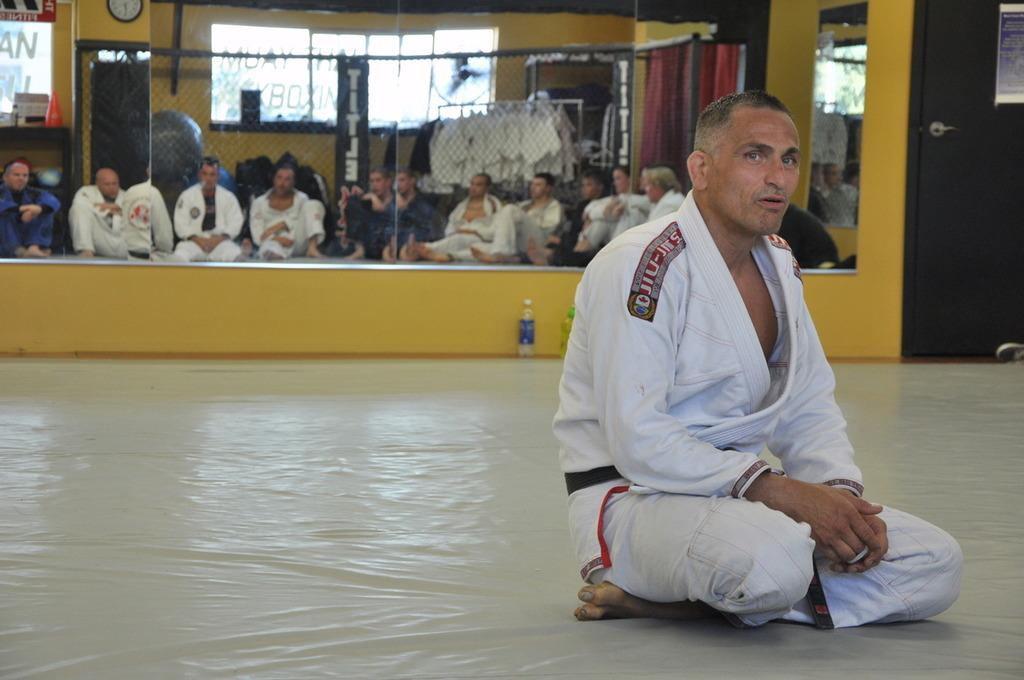<image>
Present a compact description of the photo's key features. A lone fighter sits on a mat and others watch him from in front of a sign that says "title". 